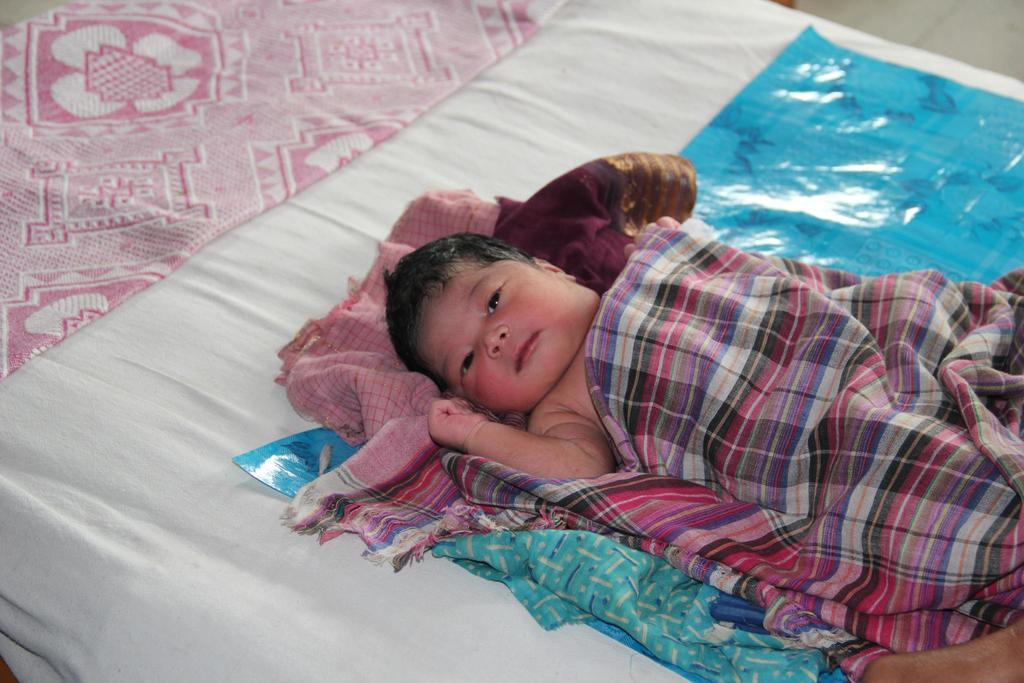What is the main subject of the image? The main subject of the image is a baby. Where is the baby located in the image? The baby is lying on a bed. What is covering the baby in the image? There is a blanket on the baby. What type of thing can be seen hanging from the window in the image? There is no window or thing hanging from it in the image; it only features a baby lying on a bed with a blanket. 